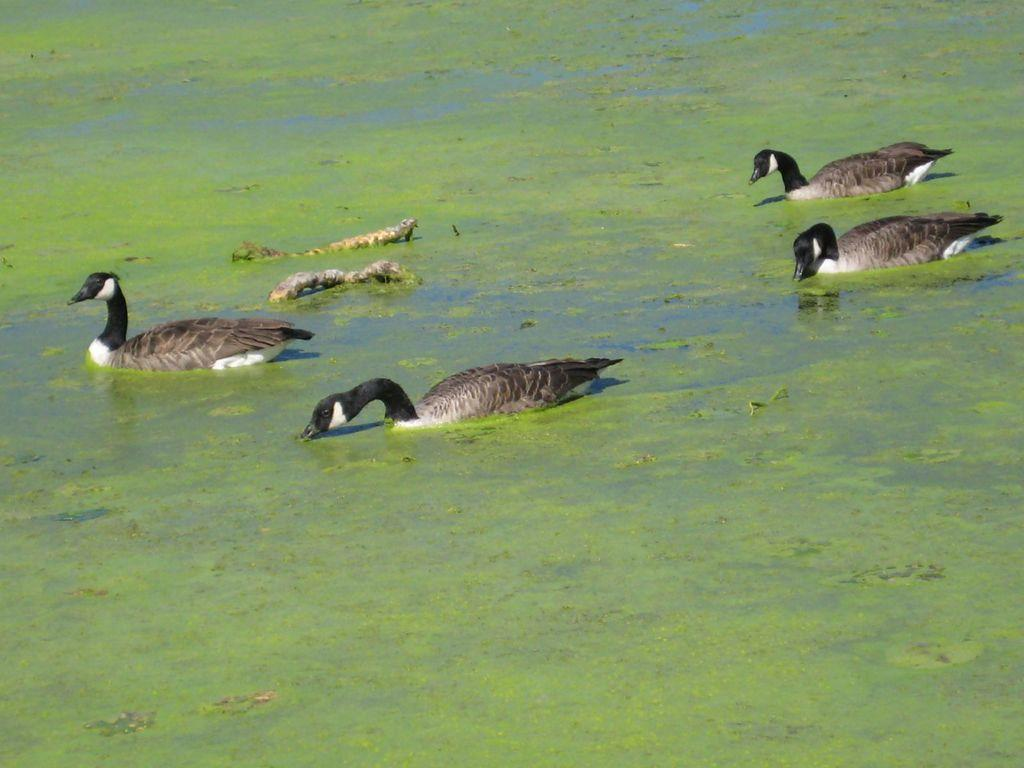What animals are present in the image? There is a group of ducks in the image. Where are the ducks located? The ducks are on the water. What type of jeans can be seen on the chin of the duck in the image? There are no jeans or any clothing items present on the ducks in the image. Are there any cacti visible in the image? There are no cacti present in the image; it features a group of ducks on the water. 